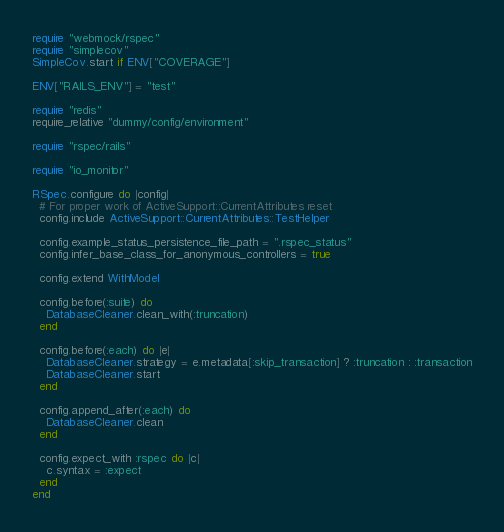<code> <loc_0><loc_0><loc_500><loc_500><_Ruby_>
require "webmock/rspec"
require "simplecov"
SimpleCov.start if ENV["COVERAGE"]

ENV["RAILS_ENV"] = "test"

require "redis"
require_relative "dummy/config/environment"

require "rspec/rails"

require "io_monitor"

RSpec.configure do |config|
  # For proper work of ActiveSupport::CurrentAttributes reset
  config.include ActiveSupport::CurrentAttributes::TestHelper

  config.example_status_persistence_file_path = ".rspec_status"
  config.infer_base_class_for_anonymous_controllers = true

  config.extend WithModel

  config.before(:suite) do
    DatabaseCleaner.clean_with(:truncation)
  end

  config.before(:each) do |e|
    DatabaseCleaner.strategy = e.metadata[:skip_transaction] ? :truncation : :transaction
    DatabaseCleaner.start
  end

  config.append_after(:each) do
    DatabaseCleaner.clean
  end

  config.expect_with :rspec do |c|
    c.syntax = :expect
  end
end
</code> 